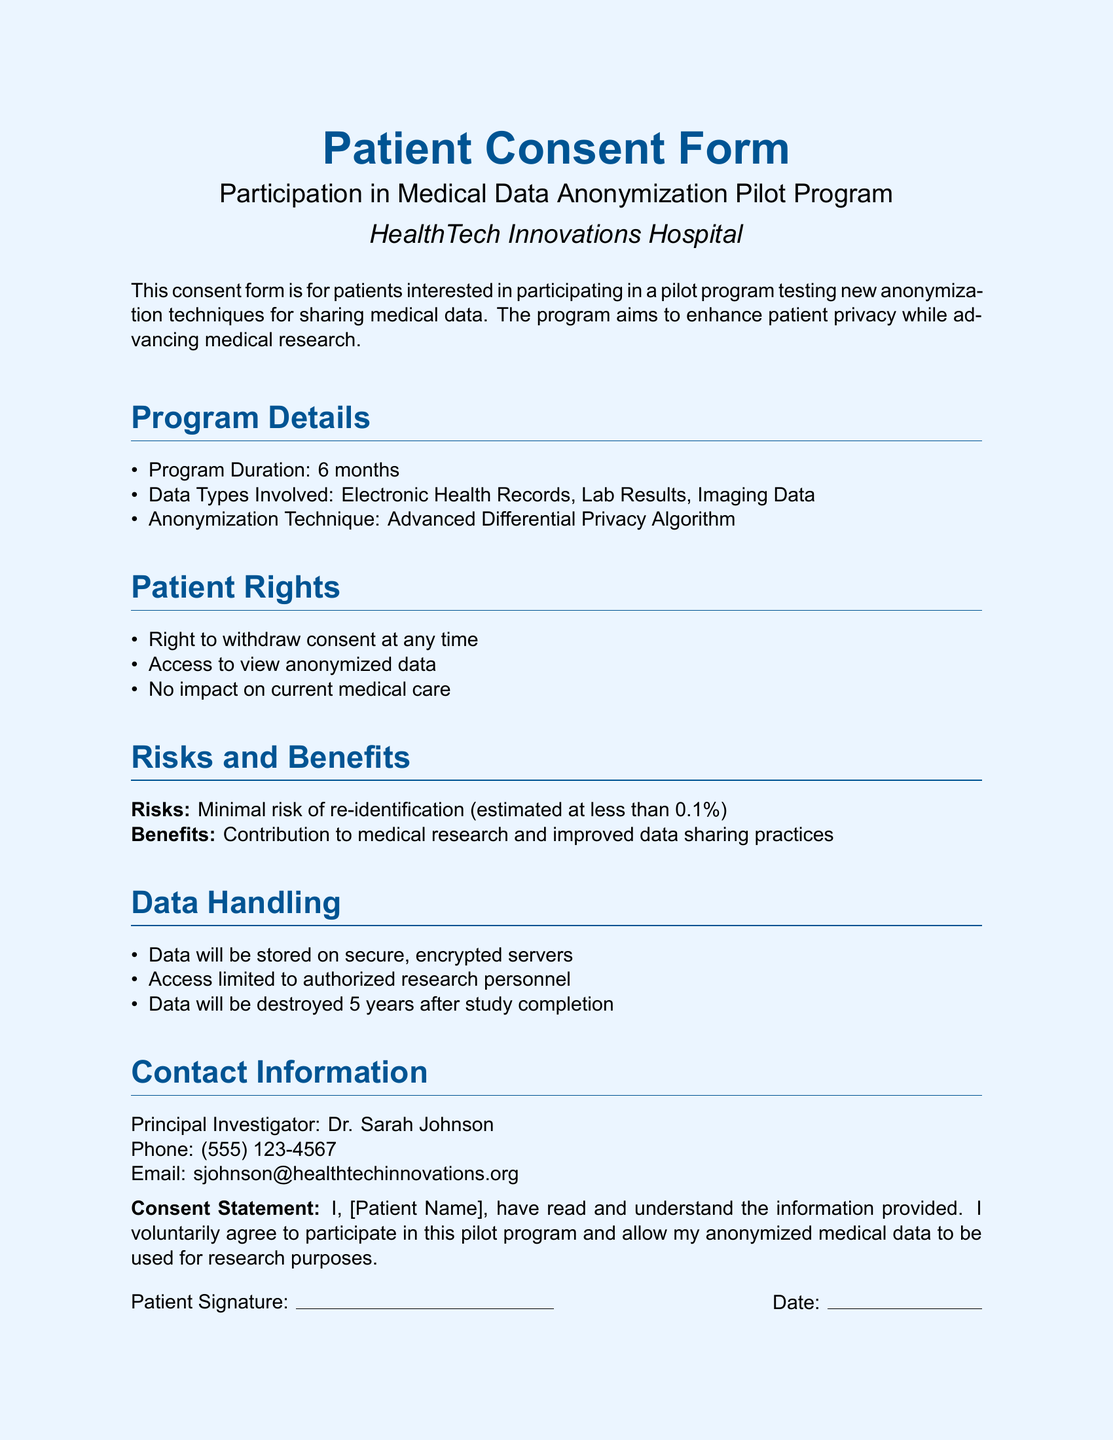What is the duration of the program? The program duration is specified in the document under Program Details as 6 months.
Answer: 6 months Who is the principal investigator? The document states that Dr. Sarah Johnson is the principal investigator responsible for the pilot program.
Answer: Dr. Sarah Johnson What data types are involved in the program? The document lists Electronic Health Records, Lab Results, and Imaging Data under Data Types Involved.
Answer: Electronic Health Records, Lab Results, Imaging Data What is the estimated risk of re-identification? The risk of re-identification is mentioned in the Risks and Benefits section as less than 0.1%.
Answer: less than 0.1% Can a patient withdraw consent? The document specifies that patients have the right to withdraw consent at any time, indicating active participation.
Answer: Yes How long will data be stored after study completion? The Data Handling section of the document states that data will be destroyed 5 years after study completion.
Answer: 5 years What kind of algorithm is being tested? The document mentions the use of an Advanced Differential Privacy Algorithm under Program Details.
Answer: Advanced Differential Privacy Algorithm What is the main benefit of participating in this program? The benefits are outlined in the Risks and Benefits section, where it states the contribution to medical research as a primary advantage.
Answer: Contribution to medical research 